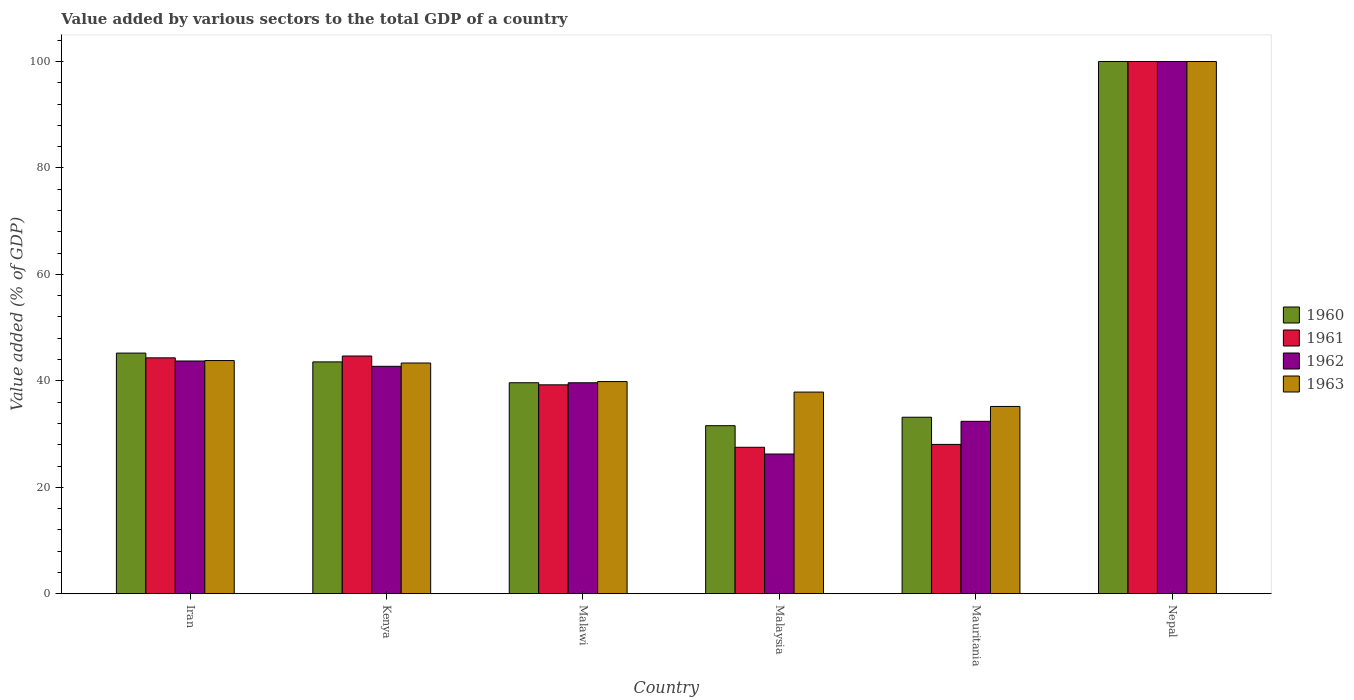How many different coloured bars are there?
Offer a terse response. 4. What is the label of the 1st group of bars from the left?
Ensure brevity in your answer.  Iran. In how many cases, is the number of bars for a given country not equal to the number of legend labels?
Give a very brief answer. 0. What is the value added by various sectors to the total GDP in 1961 in Iran?
Provide a succinct answer. 44.32. Across all countries, what is the minimum value added by various sectors to the total GDP in 1962?
Your answer should be compact. 26.25. In which country was the value added by various sectors to the total GDP in 1960 maximum?
Give a very brief answer. Nepal. In which country was the value added by various sectors to the total GDP in 1963 minimum?
Give a very brief answer. Mauritania. What is the total value added by various sectors to the total GDP in 1961 in the graph?
Your answer should be compact. 283.82. What is the difference between the value added by various sectors to the total GDP in 1960 in Malawi and that in Malaysia?
Provide a succinct answer. 8.07. What is the difference between the value added by various sectors to the total GDP in 1962 in Mauritania and the value added by various sectors to the total GDP in 1961 in Malawi?
Offer a terse response. -6.86. What is the average value added by various sectors to the total GDP in 1960 per country?
Give a very brief answer. 48.86. What is the difference between the value added by various sectors to the total GDP of/in 1963 and value added by various sectors to the total GDP of/in 1961 in Mauritania?
Give a very brief answer. 7.13. What is the ratio of the value added by various sectors to the total GDP in 1960 in Iran to that in Nepal?
Make the answer very short. 0.45. Is the value added by various sectors to the total GDP in 1963 in Iran less than that in Kenya?
Provide a succinct answer. No. Is the difference between the value added by various sectors to the total GDP in 1963 in Iran and Malaysia greater than the difference between the value added by various sectors to the total GDP in 1961 in Iran and Malaysia?
Your answer should be compact. No. What is the difference between the highest and the second highest value added by various sectors to the total GDP in 1963?
Offer a very short reply. -0.46. What is the difference between the highest and the lowest value added by various sectors to the total GDP in 1961?
Your response must be concise. 72.48. In how many countries, is the value added by various sectors to the total GDP in 1960 greater than the average value added by various sectors to the total GDP in 1960 taken over all countries?
Keep it short and to the point. 1. Is it the case that in every country, the sum of the value added by various sectors to the total GDP in 1963 and value added by various sectors to the total GDP in 1961 is greater than the sum of value added by various sectors to the total GDP in 1962 and value added by various sectors to the total GDP in 1960?
Provide a short and direct response. No. Are all the bars in the graph horizontal?
Give a very brief answer. No. How many countries are there in the graph?
Keep it short and to the point. 6. Are the values on the major ticks of Y-axis written in scientific E-notation?
Your response must be concise. No. Does the graph contain any zero values?
Provide a short and direct response. No. Does the graph contain grids?
Your response must be concise. No. Where does the legend appear in the graph?
Keep it short and to the point. Center right. How many legend labels are there?
Make the answer very short. 4. How are the legend labels stacked?
Keep it short and to the point. Vertical. What is the title of the graph?
Offer a very short reply. Value added by various sectors to the total GDP of a country. What is the label or title of the X-axis?
Your answer should be very brief. Country. What is the label or title of the Y-axis?
Keep it short and to the point. Value added (% of GDP). What is the Value added (% of GDP) in 1960 in Iran?
Offer a terse response. 45.21. What is the Value added (% of GDP) of 1961 in Iran?
Your answer should be compact. 44.32. What is the Value added (% of GDP) in 1962 in Iran?
Your response must be concise. 43.73. What is the Value added (% of GDP) in 1963 in Iran?
Give a very brief answer. 43.81. What is the Value added (% of GDP) of 1960 in Kenya?
Keep it short and to the point. 43.56. What is the Value added (% of GDP) of 1961 in Kenya?
Ensure brevity in your answer.  44.67. What is the Value added (% of GDP) of 1962 in Kenya?
Make the answer very short. 42.73. What is the Value added (% of GDP) of 1963 in Kenya?
Provide a succinct answer. 43.35. What is the Value added (% of GDP) of 1960 in Malawi?
Provide a short and direct response. 39.64. What is the Value added (% of GDP) of 1961 in Malawi?
Provide a succinct answer. 39.25. What is the Value added (% of GDP) in 1962 in Malawi?
Make the answer very short. 39.64. What is the Value added (% of GDP) of 1963 in Malawi?
Offer a terse response. 39.86. What is the Value added (% of GDP) of 1960 in Malaysia?
Make the answer very short. 31.57. What is the Value added (% of GDP) of 1961 in Malaysia?
Ensure brevity in your answer.  27.52. What is the Value added (% of GDP) in 1962 in Malaysia?
Provide a short and direct response. 26.25. What is the Value added (% of GDP) in 1963 in Malaysia?
Your answer should be very brief. 37.89. What is the Value added (% of GDP) of 1960 in Mauritania?
Your answer should be very brief. 33.17. What is the Value added (% of GDP) in 1961 in Mauritania?
Provide a short and direct response. 28.06. What is the Value added (% of GDP) in 1962 in Mauritania?
Make the answer very short. 32.4. What is the Value added (% of GDP) in 1963 in Mauritania?
Ensure brevity in your answer.  35.19. What is the Value added (% of GDP) of 1961 in Nepal?
Your answer should be very brief. 100. Across all countries, what is the minimum Value added (% of GDP) of 1960?
Your answer should be very brief. 31.57. Across all countries, what is the minimum Value added (% of GDP) in 1961?
Make the answer very short. 27.52. Across all countries, what is the minimum Value added (% of GDP) of 1962?
Give a very brief answer. 26.25. Across all countries, what is the minimum Value added (% of GDP) in 1963?
Offer a very short reply. 35.19. What is the total Value added (% of GDP) in 1960 in the graph?
Your answer should be compact. 293.16. What is the total Value added (% of GDP) of 1961 in the graph?
Offer a terse response. 283.82. What is the total Value added (% of GDP) in 1962 in the graph?
Your response must be concise. 284.74. What is the total Value added (% of GDP) in 1963 in the graph?
Your answer should be compact. 300.1. What is the difference between the Value added (% of GDP) of 1960 in Iran and that in Kenya?
Offer a terse response. 1.65. What is the difference between the Value added (% of GDP) of 1961 in Iran and that in Kenya?
Provide a short and direct response. -0.35. What is the difference between the Value added (% of GDP) in 1962 in Iran and that in Kenya?
Offer a very short reply. 1. What is the difference between the Value added (% of GDP) in 1963 in Iran and that in Kenya?
Offer a terse response. 0.46. What is the difference between the Value added (% of GDP) in 1960 in Iran and that in Malawi?
Provide a succinct answer. 5.57. What is the difference between the Value added (% of GDP) in 1961 in Iran and that in Malawi?
Your answer should be very brief. 5.07. What is the difference between the Value added (% of GDP) of 1962 in Iran and that in Malawi?
Your response must be concise. 4.09. What is the difference between the Value added (% of GDP) in 1963 in Iran and that in Malawi?
Offer a very short reply. 3.95. What is the difference between the Value added (% of GDP) of 1960 in Iran and that in Malaysia?
Keep it short and to the point. 13.64. What is the difference between the Value added (% of GDP) of 1961 in Iran and that in Malaysia?
Make the answer very short. 16.8. What is the difference between the Value added (% of GDP) in 1962 in Iran and that in Malaysia?
Give a very brief answer. 17.48. What is the difference between the Value added (% of GDP) of 1963 in Iran and that in Malaysia?
Make the answer very short. 5.92. What is the difference between the Value added (% of GDP) of 1960 in Iran and that in Mauritania?
Provide a succinct answer. 12.05. What is the difference between the Value added (% of GDP) in 1961 in Iran and that in Mauritania?
Provide a short and direct response. 16.26. What is the difference between the Value added (% of GDP) in 1962 in Iran and that in Mauritania?
Provide a succinct answer. 11.33. What is the difference between the Value added (% of GDP) of 1963 in Iran and that in Mauritania?
Provide a succinct answer. 8.62. What is the difference between the Value added (% of GDP) in 1960 in Iran and that in Nepal?
Provide a short and direct response. -54.79. What is the difference between the Value added (% of GDP) in 1961 in Iran and that in Nepal?
Offer a terse response. -55.68. What is the difference between the Value added (% of GDP) in 1962 in Iran and that in Nepal?
Ensure brevity in your answer.  -56.27. What is the difference between the Value added (% of GDP) in 1963 in Iran and that in Nepal?
Provide a short and direct response. -56.19. What is the difference between the Value added (% of GDP) of 1960 in Kenya and that in Malawi?
Offer a very short reply. 3.92. What is the difference between the Value added (% of GDP) in 1961 in Kenya and that in Malawi?
Your answer should be compact. 5.41. What is the difference between the Value added (% of GDP) of 1962 in Kenya and that in Malawi?
Your answer should be very brief. 3.1. What is the difference between the Value added (% of GDP) of 1963 in Kenya and that in Malawi?
Offer a terse response. 3.49. What is the difference between the Value added (% of GDP) in 1960 in Kenya and that in Malaysia?
Make the answer very short. 11.99. What is the difference between the Value added (% of GDP) of 1961 in Kenya and that in Malaysia?
Offer a very short reply. 17.15. What is the difference between the Value added (% of GDP) in 1962 in Kenya and that in Malaysia?
Provide a succinct answer. 16.48. What is the difference between the Value added (% of GDP) of 1963 in Kenya and that in Malaysia?
Offer a very short reply. 5.46. What is the difference between the Value added (% of GDP) of 1960 in Kenya and that in Mauritania?
Keep it short and to the point. 10.39. What is the difference between the Value added (% of GDP) in 1961 in Kenya and that in Mauritania?
Your answer should be compact. 16.61. What is the difference between the Value added (% of GDP) in 1962 in Kenya and that in Mauritania?
Offer a terse response. 10.34. What is the difference between the Value added (% of GDP) of 1963 in Kenya and that in Mauritania?
Offer a terse response. 8.16. What is the difference between the Value added (% of GDP) of 1960 in Kenya and that in Nepal?
Your answer should be very brief. -56.44. What is the difference between the Value added (% of GDP) of 1961 in Kenya and that in Nepal?
Make the answer very short. -55.33. What is the difference between the Value added (% of GDP) of 1962 in Kenya and that in Nepal?
Give a very brief answer. -57.27. What is the difference between the Value added (% of GDP) of 1963 in Kenya and that in Nepal?
Your answer should be very brief. -56.65. What is the difference between the Value added (% of GDP) in 1960 in Malawi and that in Malaysia?
Offer a terse response. 8.07. What is the difference between the Value added (% of GDP) of 1961 in Malawi and that in Malaysia?
Your answer should be compact. 11.73. What is the difference between the Value added (% of GDP) of 1962 in Malawi and that in Malaysia?
Your answer should be compact. 13.39. What is the difference between the Value added (% of GDP) of 1963 in Malawi and that in Malaysia?
Provide a succinct answer. 1.98. What is the difference between the Value added (% of GDP) of 1960 in Malawi and that in Mauritania?
Offer a terse response. 6.48. What is the difference between the Value added (% of GDP) in 1961 in Malawi and that in Mauritania?
Keep it short and to the point. 11.2. What is the difference between the Value added (% of GDP) in 1962 in Malawi and that in Mauritania?
Make the answer very short. 7.24. What is the difference between the Value added (% of GDP) in 1963 in Malawi and that in Mauritania?
Your response must be concise. 4.67. What is the difference between the Value added (% of GDP) of 1960 in Malawi and that in Nepal?
Your response must be concise. -60.36. What is the difference between the Value added (% of GDP) in 1961 in Malawi and that in Nepal?
Ensure brevity in your answer.  -60.75. What is the difference between the Value added (% of GDP) of 1962 in Malawi and that in Nepal?
Keep it short and to the point. -60.36. What is the difference between the Value added (% of GDP) in 1963 in Malawi and that in Nepal?
Offer a terse response. -60.14. What is the difference between the Value added (% of GDP) in 1960 in Malaysia and that in Mauritania?
Ensure brevity in your answer.  -1.59. What is the difference between the Value added (% of GDP) of 1961 in Malaysia and that in Mauritania?
Your answer should be very brief. -0.54. What is the difference between the Value added (% of GDP) in 1962 in Malaysia and that in Mauritania?
Give a very brief answer. -6.15. What is the difference between the Value added (% of GDP) of 1963 in Malaysia and that in Mauritania?
Give a very brief answer. 2.7. What is the difference between the Value added (% of GDP) of 1960 in Malaysia and that in Nepal?
Your response must be concise. -68.43. What is the difference between the Value added (% of GDP) in 1961 in Malaysia and that in Nepal?
Keep it short and to the point. -72.48. What is the difference between the Value added (% of GDP) of 1962 in Malaysia and that in Nepal?
Provide a short and direct response. -73.75. What is the difference between the Value added (% of GDP) in 1963 in Malaysia and that in Nepal?
Give a very brief answer. -62.11. What is the difference between the Value added (% of GDP) in 1960 in Mauritania and that in Nepal?
Ensure brevity in your answer.  -66.83. What is the difference between the Value added (% of GDP) of 1961 in Mauritania and that in Nepal?
Your response must be concise. -71.94. What is the difference between the Value added (% of GDP) in 1962 in Mauritania and that in Nepal?
Offer a terse response. -67.6. What is the difference between the Value added (% of GDP) in 1963 in Mauritania and that in Nepal?
Your response must be concise. -64.81. What is the difference between the Value added (% of GDP) of 1960 in Iran and the Value added (% of GDP) of 1961 in Kenya?
Your answer should be compact. 0.55. What is the difference between the Value added (% of GDP) in 1960 in Iran and the Value added (% of GDP) in 1962 in Kenya?
Make the answer very short. 2.48. What is the difference between the Value added (% of GDP) in 1960 in Iran and the Value added (% of GDP) in 1963 in Kenya?
Your answer should be very brief. 1.86. What is the difference between the Value added (% of GDP) in 1961 in Iran and the Value added (% of GDP) in 1962 in Kenya?
Your response must be concise. 1.59. What is the difference between the Value added (% of GDP) of 1961 in Iran and the Value added (% of GDP) of 1963 in Kenya?
Your answer should be compact. 0.97. What is the difference between the Value added (% of GDP) in 1962 in Iran and the Value added (% of GDP) in 1963 in Kenya?
Ensure brevity in your answer.  0.38. What is the difference between the Value added (% of GDP) of 1960 in Iran and the Value added (% of GDP) of 1961 in Malawi?
Provide a short and direct response. 5.96. What is the difference between the Value added (% of GDP) of 1960 in Iran and the Value added (% of GDP) of 1962 in Malawi?
Ensure brevity in your answer.  5.58. What is the difference between the Value added (% of GDP) of 1960 in Iran and the Value added (% of GDP) of 1963 in Malawi?
Your response must be concise. 5.35. What is the difference between the Value added (% of GDP) in 1961 in Iran and the Value added (% of GDP) in 1962 in Malawi?
Your answer should be very brief. 4.68. What is the difference between the Value added (% of GDP) in 1961 in Iran and the Value added (% of GDP) in 1963 in Malawi?
Offer a terse response. 4.46. What is the difference between the Value added (% of GDP) in 1962 in Iran and the Value added (% of GDP) in 1963 in Malawi?
Offer a terse response. 3.87. What is the difference between the Value added (% of GDP) of 1960 in Iran and the Value added (% of GDP) of 1961 in Malaysia?
Make the answer very short. 17.7. What is the difference between the Value added (% of GDP) of 1960 in Iran and the Value added (% of GDP) of 1962 in Malaysia?
Your answer should be compact. 18.96. What is the difference between the Value added (% of GDP) of 1960 in Iran and the Value added (% of GDP) of 1963 in Malaysia?
Provide a succinct answer. 7.33. What is the difference between the Value added (% of GDP) of 1961 in Iran and the Value added (% of GDP) of 1962 in Malaysia?
Your response must be concise. 18.07. What is the difference between the Value added (% of GDP) of 1961 in Iran and the Value added (% of GDP) of 1963 in Malaysia?
Your response must be concise. 6.43. What is the difference between the Value added (% of GDP) in 1962 in Iran and the Value added (% of GDP) in 1963 in Malaysia?
Your answer should be compact. 5.84. What is the difference between the Value added (% of GDP) of 1960 in Iran and the Value added (% of GDP) of 1961 in Mauritania?
Offer a terse response. 17.16. What is the difference between the Value added (% of GDP) in 1960 in Iran and the Value added (% of GDP) in 1962 in Mauritania?
Offer a very short reply. 12.82. What is the difference between the Value added (% of GDP) in 1960 in Iran and the Value added (% of GDP) in 1963 in Mauritania?
Offer a terse response. 10.02. What is the difference between the Value added (% of GDP) in 1961 in Iran and the Value added (% of GDP) in 1962 in Mauritania?
Ensure brevity in your answer.  11.92. What is the difference between the Value added (% of GDP) of 1961 in Iran and the Value added (% of GDP) of 1963 in Mauritania?
Ensure brevity in your answer.  9.13. What is the difference between the Value added (% of GDP) in 1962 in Iran and the Value added (% of GDP) in 1963 in Mauritania?
Your answer should be compact. 8.54. What is the difference between the Value added (% of GDP) in 1960 in Iran and the Value added (% of GDP) in 1961 in Nepal?
Ensure brevity in your answer.  -54.79. What is the difference between the Value added (% of GDP) of 1960 in Iran and the Value added (% of GDP) of 1962 in Nepal?
Make the answer very short. -54.79. What is the difference between the Value added (% of GDP) of 1960 in Iran and the Value added (% of GDP) of 1963 in Nepal?
Your answer should be very brief. -54.79. What is the difference between the Value added (% of GDP) of 1961 in Iran and the Value added (% of GDP) of 1962 in Nepal?
Give a very brief answer. -55.68. What is the difference between the Value added (% of GDP) in 1961 in Iran and the Value added (% of GDP) in 1963 in Nepal?
Your response must be concise. -55.68. What is the difference between the Value added (% of GDP) in 1962 in Iran and the Value added (% of GDP) in 1963 in Nepal?
Give a very brief answer. -56.27. What is the difference between the Value added (% of GDP) of 1960 in Kenya and the Value added (% of GDP) of 1961 in Malawi?
Offer a very short reply. 4.31. What is the difference between the Value added (% of GDP) in 1960 in Kenya and the Value added (% of GDP) in 1962 in Malawi?
Your answer should be very brief. 3.92. What is the difference between the Value added (% of GDP) of 1960 in Kenya and the Value added (% of GDP) of 1963 in Malawi?
Make the answer very short. 3.7. What is the difference between the Value added (% of GDP) in 1961 in Kenya and the Value added (% of GDP) in 1962 in Malawi?
Make the answer very short. 5.03. What is the difference between the Value added (% of GDP) in 1961 in Kenya and the Value added (% of GDP) in 1963 in Malawi?
Provide a succinct answer. 4.8. What is the difference between the Value added (% of GDP) in 1962 in Kenya and the Value added (% of GDP) in 1963 in Malawi?
Ensure brevity in your answer.  2.87. What is the difference between the Value added (% of GDP) of 1960 in Kenya and the Value added (% of GDP) of 1961 in Malaysia?
Make the answer very short. 16.04. What is the difference between the Value added (% of GDP) of 1960 in Kenya and the Value added (% of GDP) of 1962 in Malaysia?
Provide a short and direct response. 17.31. What is the difference between the Value added (% of GDP) in 1960 in Kenya and the Value added (% of GDP) in 1963 in Malaysia?
Offer a terse response. 5.67. What is the difference between the Value added (% of GDP) in 1961 in Kenya and the Value added (% of GDP) in 1962 in Malaysia?
Offer a very short reply. 18.42. What is the difference between the Value added (% of GDP) in 1961 in Kenya and the Value added (% of GDP) in 1963 in Malaysia?
Give a very brief answer. 6.78. What is the difference between the Value added (% of GDP) of 1962 in Kenya and the Value added (% of GDP) of 1963 in Malaysia?
Provide a short and direct response. 4.84. What is the difference between the Value added (% of GDP) in 1960 in Kenya and the Value added (% of GDP) in 1961 in Mauritania?
Make the answer very short. 15.5. What is the difference between the Value added (% of GDP) in 1960 in Kenya and the Value added (% of GDP) in 1962 in Mauritania?
Keep it short and to the point. 11.16. What is the difference between the Value added (% of GDP) in 1960 in Kenya and the Value added (% of GDP) in 1963 in Mauritania?
Keep it short and to the point. 8.37. What is the difference between the Value added (% of GDP) of 1961 in Kenya and the Value added (% of GDP) of 1962 in Mauritania?
Provide a short and direct response. 12.27. What is the difference between the Value added (% of GDP) in 1961 in Kenya and the Value added (% of GDP) in 1963 in Mauritania?
Make the answer very short. 9.48. What is the difference between the Value added (% of GDP) of 1962 in Kenya and the Value added (% of GDP) of 1963 in Mauritania?
Keep it short and to the point. 7.54. What is the difference between the Value added (% of GDP) of 1960 in Kenya and the Value added (% of GDP) of 1961 in Nepal?
Give a very brief answer. -56.44. What is the difference between the Value added (% of GDP) in 1960 in Kenya and the Value added (% of GDP) in 1962 in Nepal?
Your answer should be compact. -56.44. What is the difference between the Value added (% of GDP) of 1960 in Kenya and the Value added (% of GDP) of 1963 in Nepal?
Give a very brief answer. -56.44. What is the difference between the Value added (% of GDP) of 1961 in Kenya and the Value added (% of GDP) of 1962 in Nepal?
Your answer should be compact. -55.33. What is the difference between the Value added (% of GDP) of 1961 in Kenya and the Value added (% of GDP) of 1963 in Nepal?
Ensure brevity in your answer.  -55.33. What is the difference between the Value added (% of GDP) in 1962 in Kenya and the Value added (% of GDP) in 1963 in Nepal?
Offer a terse response. -57.27. What is the difference between the Value added (% of GDP) of 1960 in Malawi and the Value added (% of GDP) of 1961 in Malaysia?
Ensure brevity in your answer.  12.13. What is the difference between the Value added (% of GDP) in 1960 in Malawi and the Value added (% of GDP) in 1962 in Malaysia?
Give a very brief answer. 13.39. What is the difference between the Value added (% of GDP) of 1960 in Malawi and the Value added (% of GDP) of 1963 in Malaysia?
Make the answer very short. 1.76. What is the difference between the Value added (% of GDP) in 1961 in Malawi and the Value added (% of GDP) in 1962 in Malaysia?
Provide a succinct answer. 13. What is the difference between the Value added (% of GDP) in 1961 in Malawi and the Value added (% of GDP) in 1963 in Malaysia?
Provide a short and direct response. 1.37. What is the difference between the Value added (% of GDP) in 1962 in Malawi and the Value added (% of GDP) in 1963 in Malaysia?
Keep it short and to the point. 1.75. What is the difference between the Value added (% of GDP) in 1960 in Malawi and the Value added (% of GDP) in 1961 in Mauritania?
Your answer should be very brief. 11.59. What is the difference between the Value added (% of GDP) in 1960 in Malawi and the Value added (% of GDP) in 1962 in Mauritania?
Provide a succinct answer. 7.25. What is the difference between the Value added (% of GDP) of 1960 in Malawi and the Value added (% of GDP) of 1963 in Mauritania?
Ensure brevity in your answer.  4.45. What is the difference between the Value added (% of GDP) in 1961 in Malawi and the Value added (% of GDP) in 1962 in Mauritania?
Offer a very short reply. 6.86. What is the difference between the Value added (% of GDP) in 1961 in Malawi and the Value added (% of GDP) in 1963 in Mauritania?
Your answer should be very brief. 4.06. What is the difference between the Value added (% of GDP) in 1962 in Malawi and the Value added (% of GDP) in 1963 in Mauritania?
Provide a succinct answer. 4.45. What is the difference between the Value added (% of GDP) of 1960 in Malawi and the Value added (% of GDP) of 1961 in Nepal?
Ensure brevity in your answer.  -60.36. What is the difference between the Value added (% of GDP) of 1960 in Malawi and the Value added (% of GDP) of 1962 in Nepal?
Provide a succinct answer. -60.36. What is the difference between the Value added (% of GDP) of 1960 in Malawi and the Value added (% of GDP) of 1963 in Nepal?
Your response must be concise. -60.36. What is the difference between the Value added (% of GDP) in 1961 in Malawi and the Value added (% of GDP) in 1962 in Nepal?
Keep it short and to the point. -60.75. What is the difference between the Value added (% of GDP) of 1961 in Malawi and the Value added (% of GDP) of 1963 in Nepal?
Your answer should be compact. -60.75. What is the difference between the Value added (% of GDP) of 1962 in Malawi and the Value added (% of GDP) of 1963 in Nepal?
Provide a short and direct response. -60.36. What is the difference between the Value added (% of GDP) in 1960 in Malaysia and the Value added (% of GDP) in 1961 in Mauritania?
Keep it short and to the point. 3.51. What is the difference between the Value added (% of GDP) in 1960 in Malaysia and the Value added (% of GDP) in 1962 in Mauritania?
Your answer should be very brief. -0.82. What is the difference between the Value added (% of GDP) in 1960 in Malaysia and the Value added (% of GDP) in 1963 in Mauritania?
Offer a very short reply. -3.62. What is the difference between the Value added (% of GDP) of 1961 in Malaysia and the Value added (% of GDP) of 1962 in Mauritania?
Ensure brevity in your answer.  -4.88. What is the difference between the Value added (% of GDP) in 1961 in Malaysia and the Value added (% of GDP) in 1963 in Mauritania?
Offer a terse response. -7.67. What is the difference between the Value added (% of GDP) in 1962 in Malaysia and the Value added (% of GDP) in 1963 in Mauritania?
Provide a short and direct response. -8.94. What is the difference between the Value added (% of GDP) in 1960 in Malaysia and the Value added (% of GDP) in 1961 in Nepal?
Give a very brief answer. -68.43. What is the difference between the Value added (% of GDP) in 1960 in Malaysia and the Value added (% of GDP) in 1962 in Nepal?
Your answer should be very brief. -68.43. What is the difference between the Value added (% of GDP) in 1960 in Malaysia and the Value added (% of GDP) in 1963 in Nepal?
Offer a terse response. -68.43. What is the difference between the Value added (% of GDP) in 1961 in Malaysia and the Value added (% of GDP) in 1962 in Nepal?
Your answer should be very brief. -72.48. What is the difference between the Value added (% of GDP) of 1961 in Malaysia and the Value added (% of GDP) of 1963 in Nepal?
Your response must be concise. -72.48. What is the difference between the Value added (% of GDP) of 1962 in Malaysia and the Value added (% of GDP) of 1963 in Nepal?
Give a very brief answer. -73.75. What is the difference between the Value added (% of GDP) in 1960 in Mauritania and the Value added (% of GDP) in 1961 in Nepal?
Offer a terse response. -66.83. What is the difference between the Value added (% of GDP) of 1960 in Mauritania and the Value added (% of GDP) of 1962 in Nepal?
Your response must be concise. -66.83. What is the difference between the Value added (% of GDP) in 1960 in Mauritania and the Value added (% of GDP) in 1963 in Nepal?
Give a very brief answer. -66.83. What is the difference between the Value added (% of GDP) in 1961 in Mauritania and the Value added (% of GDP) in 1962 in Nepal?
Provide a short and direct response. -71.94. What is the difference between the Value added (% of GDP) in 1961 in Mauritania and the Value added (% of GDP) in 1963 in Nepal?
Make the answer very short. -71.94. What is the difference between the Value added (% of GDP) of 1962 in Mauritania and the Value added (% of GDP) of 1963 in Nepal?
Ensure brevity in your answer.  -67.6. What is the average Value added (% of GDP) of 1960 per country?
Your answer should be very brief. 48.86. What is the average Value added (% of GDP) in 1961 per country?
Keep it short and to the point. 47.3. What is the average Value added (% of GDP) in 1962 per country?
Your response must be concise. 47.46. What is the average Value added (% of GDP) in 1963 per country?
Provide a short and direct response. 50.02. What is the difference between the Value added (% of GDP) in 1960 and Value added (% of GDP) in 1961 in Iran?
Ensure brevity in your answer.  0.89. What is the difference between the Value added (% of GDP) of 1960 and Value added (% of GDP) of 1962 in Iran?
Your response must be concise. 1.48. What is the difference between the Value added (% of GDP) of 1960 and Value added (% of GDP) of 1963 in Iran?
Keep it short and to the point. 1.4. What is the difference between the Value added (% of GDP) of 1961 and Value added (% of GDP) of 1962 in Iran?
Offer a very short reply. 0.59. What is the difference between the Value added (% of GDP) in 1961 and Value added (% of GDP) in 1963 in Iran?
Provide a succinct answer. 0.51. What is the difference between the Value added (% of GDP) of 1962 and Value added (% of GDP) of 1963 in Iran?
Offer a terse response. -0.08. What is the difference between the Value added (% of GDP) in 1960 and Value added (% of GDP) in 1961 in Kenya?
Your answer should be very brief. -1.11. What is the difference between the Value added (% of GDP) of 1960 and Value added (% of GDP) of 1962 in Kenya?
Provide a succinct answer. 0.83. What is the difference between the Value added (% of GDP) of 1960 and Value added (% of GDP) of 1963 in Kenya?
Your answer should be compact. 0.21. What is the difference between the Value added (% of GDP) in 1961 and Value added (% of GDP) in 1962 in Kenya?
Your response must be concise. 1.94. What is the difference between the Value added (% of GDP) of 1961 and Value added (% of GDP) of 1963 in Kenya?
Keep it short and to the point. 1.32. What is the difference between the Value added (% of GDP) in 1962 and Value added (% of GDP) in 1963 in Kenya?
Offer a very short reply. -0.62. What is the difference between the Value added (% of GDP) of 1960 and Value added (% of GDP) of 1961 in Malawi?
Provide a short and direct response. 0.39. What is the difference between the Value added (% of GDP) in 1960 and Value added (% of GDP) in 1962 in Malawi?
Keep it short and to the point. 0.01. What is the difference between the Value added (% of GDP) of 1960 and Value added (% of GDP) of 1963 in Malawi?
Make the answer very short. -0.22. What is the difference between the Value added (% of GDP) of 1961 and Value added (% of GDP) of 1962 in Malawi?
Give a very brief answer. -0.38. What is the difference between the Value added (% of GDP) of 1961 and Value added (% of GDP) of 1963 in Malawi?
Provide a short and direct response. -0.61. What is the difference between the Value added (% of GDP) of 1962 and Value added (% of GDP) of 1963 in Malawi?
Offer a terse response. -0.23. What is the difference between the Value added (% of GDP) of 1960 and Value added (% of GDP) of 1961 in Malaysia?
Your answer should be very brief. 4.05. What is the difference between the Value added (% of GDP) in 1960 and Value added (% of GDP) in 1962 in Malaysia?
Provide a short and direct response. 5.32. What is the difference between the Value added (% of GDP) in 1960 and Value added (% of GDP) in 1963 in Malaysia?
Make the answer very short. -6.31. What is the difference between the Value added (% of GDP) of 1961 and Value added (% of GDP) of 1962 in Malaysia?
Your answer should be compact. 1.27. What is the difference between the Value added (% of GDP) in 1961 and Value added (% of GDP) in 1963 in Malaysia?
Your answer should be compact. -10.37. What is the difference between the Value added (% of GDP) in 1962 and Value added (% of GDP) in 1963 in Malaysia?
Your answer should be compact. -11.64. What is the difference between the Value added (% of GDP) in 1960 and Value added (% of GDP) in 1961 in Mauritania?
Give a very brief answer. 5.11. What is the difference between the Value added (% of GDP) in 1960 and Value added (% of GDP) in 1962 in Mauritania?
Your answer should be compact. 0.77. What is the difference between the Value added (% of GDP) of 1960 and Value added (% of GDP) of 1963 in Mauritania?
Offer a terse response. -2.02. What is the difference between the Value added (% of GDP) in 1961 and Value added (% of GDP) in 1962 in Mauritania?
Ensure brevity in your answer.  -4.34. What is the difference between the Value added (% of GDP) in 1961 and Value added (% of GDP) in 1963 in Mauritania?
Keep it short and to the point. -7.13. What is the difference between the Value added (% of GDP) of 1962 and Value added (% of GDP) of 1963 in Mauritania?
Offer a terse response. -2.79. What is the difference between the Value added (% of GDP) in 1960 and Value added (% of GDP) in 1961 in Nepal?
Give a very brief answer. 0. What is the difference between the Value added (% of GDP) of 1961 and Value added (% of GDP) of 1962 in Nepal?
Provide a short and direct response. 0. What is the difference between the Value added (% of GDP) in 1961 and Value added (% of GDP) in 1963 in Nepal?
Your answer should be compact. 0. What is the ratio of the Value added (% of GDP) of 1960 in Iran to that in Kenya?
Keep it short and to the point. 1.04. What is the ratio of the Value added (% of GDP) of 1961 in Iran to that in Kenya?
Your answer should be very brief. 0.99. What is the ratio of the Value added (% of GDP) of 1962 in Iran to that in Kenya?
Give a very brief answer. 1.02. What is the ratio of the Value added (% of GDP) in 1963 in Iran to that in Kenya?
Give a very brief answer. 1.01. What is the ratio of the Value added (% of GDP) of 1960 in Iran to that in Malawi?
Ensure brevity in your answer.  1.14. What is the ratio of the Value added (% of GDP) in 1961 in Iran to that in Malawi?
Your answer should be very brief. 1.13. What is the ratio of the Value added (% of GDP) of 1962 in Iran to that in Malawi?
Your answer should be compact. 1.1. What is the ratio of the Value added (% of GDP) in 1963 in Iran to that in Malawi?
Make the answer very short. 1.1. What is the ratio of the Value added (% of GDP) in 1960 in Iran to that in Malaysia?
Your answer should be very brief. 1.43. What is the ratio of the Value added (% of GDP) in 1961 in Iran to that in Malaysia?
Offer a very short reply. 1.61. What is the ratio of the Value added (% of GDP) of 1962 in Iran to that in Malaysia?
Make the answer very short. 1.67. What is the ratio of the Value added (% of GDP) in 1963 in Iran to that in Malaysia?
Give a very brief answer. 1.16. What is the ratio of the Value added (% of GDP) in 1960 in Iran to that in Mauritania?
Give a very brief answer. 1.36. What is the ratio of the Value added (% of GDP) in 1961 in Iran to that in Mauritania?
Your response must be concise. 1.58. What is the ratio of the Value added (% of GDP) in 1962 in Iran to that in Mauritania?
Provide a succinct answer. 1.35. What is the ratio of the Value added (% of GDP) of 1963 in Iran to that in Mauritania?
Give a very brief answer. 1.25. What is the ratio of the Value added (% of GDP) in 1960 in Iran to that in Nepal?
Ensure brevity in your answer.  0.45. What is the ratio of the Value added (% of GDP) in 1961 in Iran to that in Nepal?
Offer a terse response. 0.44. What is the ratio of the Value added (% of GDP) in 1962 in Iran to that in Nepal?
Provide a succinct answer. 0.44. What is the ratio of the Value added (% of GDP) of 1963 in Iran to that in Nepal?
Your answer should be compact. 0.44. What is the ratio of the Value added (% of GDP) in 1960 in Kenya to that in Malawi?
Provide a succinct answer. 1.1. What is the ratio of the Value added (% of GDP) in 1961 in Kenya to that in Malawi?
Ensure brevity in your answer.  1.14. What is the ratio of the Value added (% of GDP) in 1962 in Kenya to that in Malawi?
Your answer should be compact. 1.08. What is the ratio of the Value added (% of GDP) of 1963 in Kenya to that in Malawi?
Give a very brief answer. 1.09. What is the ratio of the Value added (% of GDP) of 1960 in Kenya to that in Malaysia?
Offer a terse response. 1.38. What is the ratio of the Value added (% of GDP) in 1961 in Kenya to that in Malaysia?
Keep it short and to the point. 1.62. What is the ratio of the Value added (% of GDP) of 1962 in Kenya to that in Malaysia?
Give a very brief answer. 1.63. What is the ratio of the Value added (% of GDP) of 1963 in Kenya to that in Malaysia?
Your answer should be compact. 1.14. What is the ratio of the Value added (% of GDP) in 1960 in Kenya to that in Mauritania?
Offer a very short reply. 1.31. What is the ratio of the Value added (% of GDP) in 1961 in Kenya to that in Mauritania?
Ensure brevity in your answer.  1.59. What is the ratio of the Value added (% of GDP) in 1962 in Kenya to that in Mauritania?
Your response must be concise. 1.32. What is the ratio of the Value added (% of GDP) of 1963 in Kenya to that in Mauritania?
Your response must be concise. 1.23. What is the ratio of the Value added (% of GDP) of 1960 in Kenya to that in Nepal?
Offer a terse response. 0.44. What is the ratio of the Value added (% of GDP) of 1961 in Kenya to that in Nepal?
Provide a short and direct response. 0.45. What is the ratio of the Value added (% of GDP) of 1962 in Kenya to that in Nepal?
Keep it short and to the point. 0.43. What is the ratio of the Value added (% of GDP) in 1963 in Kenya to that in Nepal?
Your answer should be compact. 0.43. What is the ratio of the Value added (% of GDP) in 1960 in Malawi to that in Malaysia?
Your answer should be compact. 1.26. What is the ratio of the Value added (% of GDP) in 1961 in Malawi to that in Malaysia?
Make the answer very short. 1.43. What is the ratio of the Value added (% of GDP) of 1962 in Malawi to that in Malaysia?
Offer a terse response. 1.51. What is the ratio of the Value added (% of GDP) of 1963 in Malawi to that in Malaysia?
Provide a short and direct response. 1.05. What is the ratio of the Value added (% of GDP) of 1960 in Malawi to that in Mauritania?
Provide a short and direct response. 1.2. What is the ratio of the Value added (% of GDP) of 1961 in Malawi to that in Mauritania?
Your answer should be compact. 1.4. What is the ratio of the Value added (% of GDP) in 1962 in Malawi to that in Mauritania?
Your answer should be very brief. 1.22. What is the ratio of the Value added (% of GDP) of 1963 in Malawi to that in Mauritania?
Keep it short and to the point. 1.13. What is the ratio of the Value added (% of GDP) of 1960 in Malawi to that in Nepal?
Provide a succinct answer. 0.4. What is the ratio of the Value added (% of GDP) of 1961 in Malawi to that in Nepal?
Your answer should be very brief. 0.39. What is the ratio of the Value added (% of GDP) of 1962 in Malawi to that in Nepal?
Your response must be concise. 0.4. What is the ratio of the Value added (% of GDP) in 1963 in Malawi to that in Nepal?
Your response must be concise. 0.4. What is the ratio of the Value added (% of GDP) in 1961 in Malaysia to that in Mauritania?
Offer a very short reply. 0.98. What is the ratio of the Value added (% of GDP) in 1962 in Malaysia to that in Mauritania?
Make the answer very short. 0.81. What is the ratio of the Value added (% of GDP) of 1963 in Malaysia to that in Mauritania?
Make the answer very short. 1.08. What is the ratio of the Value added (% of GDP) in 1960 in Malaysia to that in Nepal?
Give a very brief answer. 0.32. What is the ratio of the Value added (% of GDP) in 1961 in Malaysia to that in Nepal?
Your answer should be compact. 0.28. What is the ratio of the Value added (% of GDP) of 1962 in Malaysia to that in Nepal?
Provide a succinct answer. 0.26. What is the ratio of the Value added (% of GDP) in 1963 in Malaysia to that in Nepal?
Your answer should be very brief. 0.38. What is the ratio of the Value added (% of GDP) of 1960 in Mauritania to that in Nepal?
Provide a succinct answer. 0.33. What is the ratio of the Value added (% of GDP) of 1961 in Mauritania to that in Nepal?
Your response must be concise. 0.28. What is the ratio of the Value added (% of GDP) of 1962 in Mauritania to that in Nepal?
Your answer should be very brief. 0.32. What is the ratio of the Value added (% of GDP) in 1963 in Mauritania to that in Nepal?
Give a very brief answer. 0.35. What is the difference between the highest and the second highest Value added (% of GDP) of 1960?
Provide a succinct answer. 54.79. What is the difference between the highest and the second highest Value added (% of GDP) of 1961?
Make the answer very short. 55.33. What is the difference between the highest and the second highest Value added (% of GDP) in 1962?
Offer a terse response. 56.27. What is the difference between the highest and the second highest Value added (% of GDP) in 1963?
Your answer should be very brief. 56.19. What is the difference between the highest and the lowest Value added (% of GDP) in 1960?
Your response must be concise. 68.43. What is the difference between the highest and the lowest Value added (% of GDP) of 1961?
Your answer should be compact. 72.48. What is the difference between the highest and the lowest Value added (% of GDP) of 1962?
Ensure brevity in your answer.  73.75. What is the difference between the highest and the lowest Value added (% of GDP) in 1963?
Offer a terse response. 64.81. 